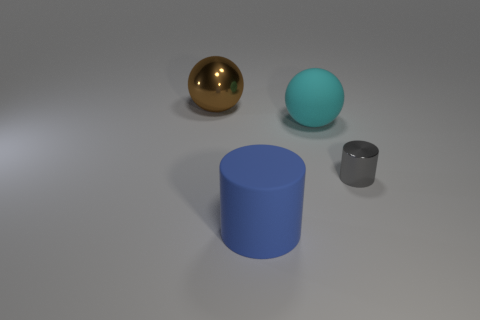Add 4 large cylinders. How many objects exist? 8 Subtract all cyan balls. How many balls are left? 1 Add 1 small red cylinders. How many small red cylinders exist? 1 Subtract 0 blue spheres. How many objects are left? 4 Subtract 1 spheres. How many spheres are left? 1 Subtract all yellow spheres. Subtract all cyan cylinders. How many spheres are left? 2 Subtract all big green metallic cubes. Subtract all large blue objects. How many objects are left? 3 Add 3 large shiny spheres. How many large shiny spheres are left? 4 